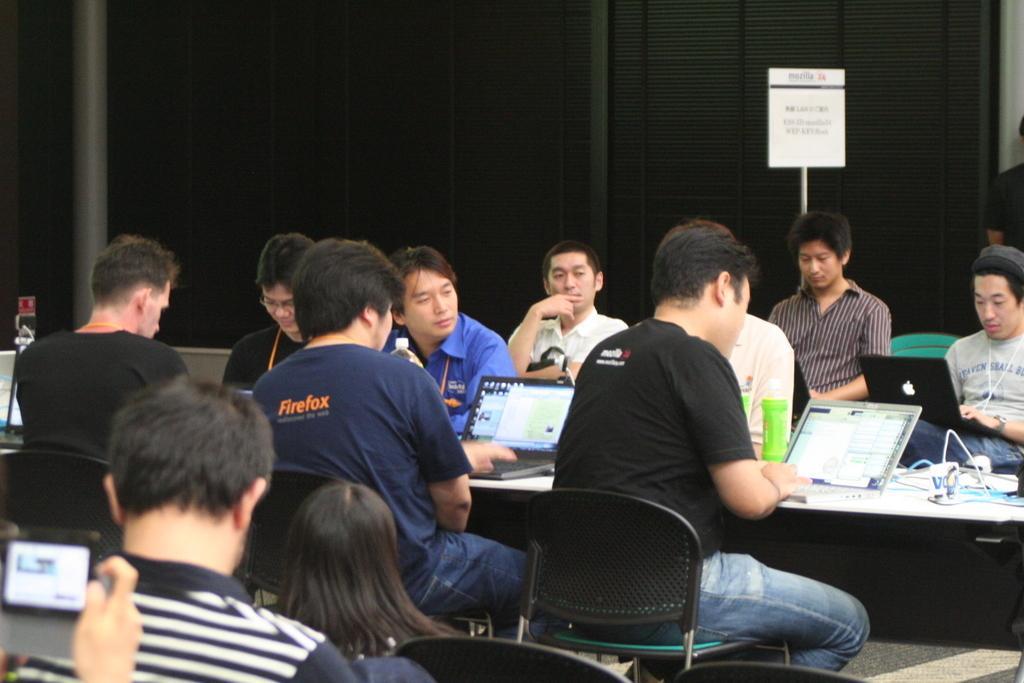How would you summarize this image in a sentence or two? This is a meeting hall. many people are sitting on chairs. in front of them there is table. On table there are laptops,bottle. In the background there is wall. 